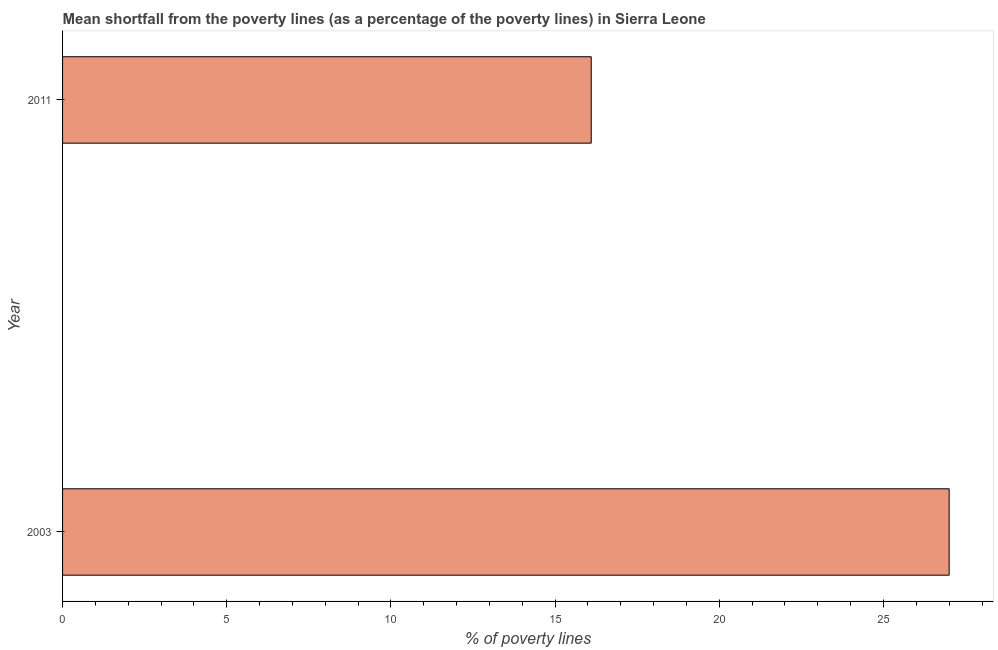Does the graph contain any zero values?
Provide a succinct answer. No. Does the graph contain grids?
Make the answer very short. No. What is the title of the graph?
Ensure brevity in your answer.  Mean shortfall from the poverty lines (as a percentage of the poverty lines) in Sierra Leone. What is the label or title of the X-axis?
Offer a terse response. % of poverty lines. What is the label or title of the Y-axis?
Keep it short and to the point. Year. Across all years, what is the maximum poverty gap at national poverty lines?
Give a very brief answer. 27. Across all years, what is the minimum poverty gap at national poverty lines?
Provide a succinct answer. 16.1. In which year was the poverty gap at national poverty lines maximum?
Make the answer very short. 2003. In which year was the poverty gap at national poverty lines minimum?
Give a very brief answer. 2011. What is the sum of the poverty gap at national poverty lines?
Provide a succinct answer. 43.1. What is the difference between the poverty gap at national poverty lines in 2003 and 2011?
Your answer should be very brief. 10.9. What is the average poverty gap at national poverty lines per year?
Ensure brevity in your answer.  21.55. What is the median poverty gap at national poverty lines?
Give a very brief answer. 21.55. In how many years, is the poverty gap at national poverty lines greater than 2 %?
Your response must be concise. 2. What is the ratio of the poverty gap at national poverty lines in 2003 to that in 2011?
Ensure brevity in your answer.  1.68. Is the poverty gap at national poverty lines in 2003 less than that in 2011?
Make the answer very short. No. In how many years, is the poverty gap at national poverty lines greater than the average poverty gap at national poverty lines taken over all years?
Keep it short and to the point. 1. Are all the bars in the graph horizontal?
Provide a succinct answer. Yes. What is the difference between two consecutive major ticks on the X-axis?
Offer a terse response. 5. What is the % of poverty lines of 2003?
Offer a terse response. 27. What is the % of poverty lines in 2011?
Offer a terse response. 16.1. What is the difference between the % of poverty lines in 2003 and 2011?
Offer a terse response. 10.9. What is the ratio of the % of poverty lines in 2003 to that in 2011?
Your answer should be very brief. 1.68. 